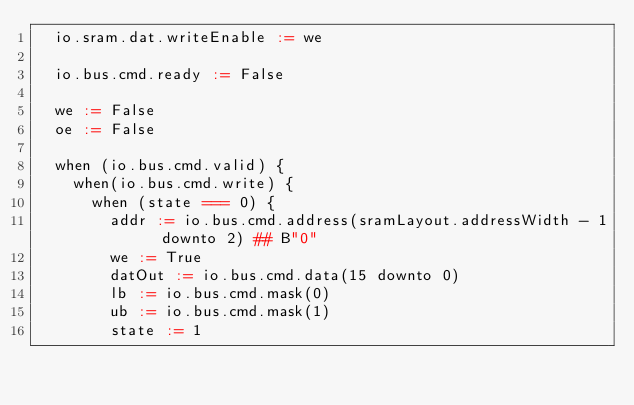<code> <loc_0><loc_0><loc_500><loc_500><_Scala_>  io.sram.dat.writeEnable := we

  io.bus.cmd.ready := False
    
  we := False
  oe := False

  when (io.bus.cmd.valid) {
    when(io.bus.cmd.write) {
      when (state === 0) {
        addr := io.bus.cmd.address(sramLayout.addressWidth - 1  downto 2) ## B"0"
        we := True
        datOut := io.bus.cmd.data(15 downto 0)
        lb := io.bus.cmd.mask(0)
        ub := io.bus.cmd.mask(1)
        state := 1</code> 